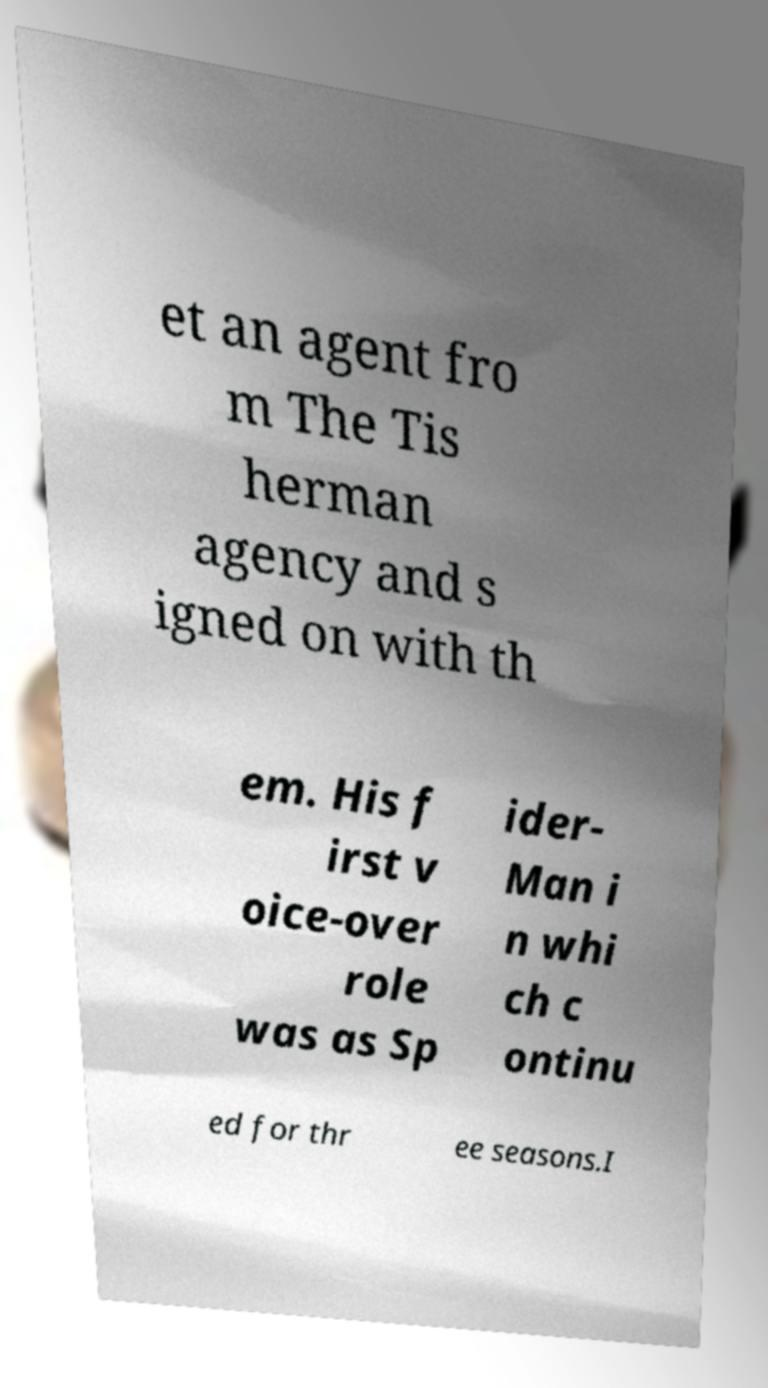Please identify and transcribe the text found in this image. et an agent fro m The Tis herman agency and s igned on with th em. His f irst v oice-over role was as Sp ider- Man i n whi ch c ontinu ed for thr ee seasons.I 